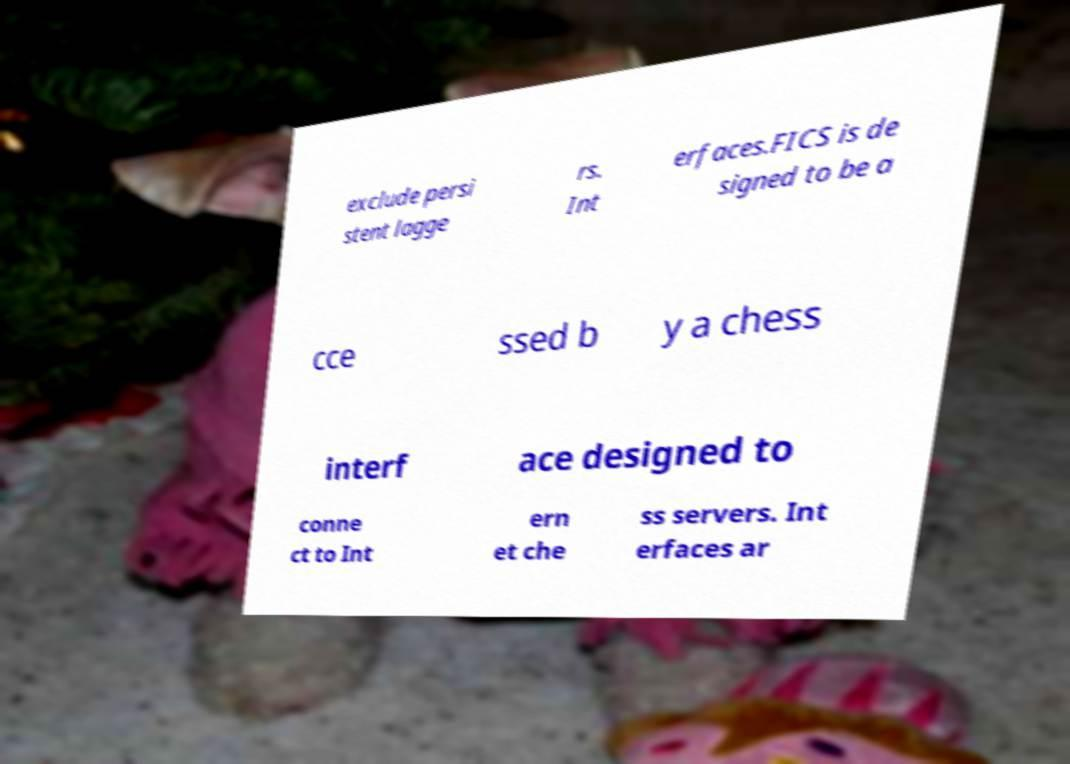Can you accurately transcribe the text from the provided image for me? exclude persi stent lagge rs. Int erfaces.FICS is de signed to be a cce ssed b y a chess interf ace designed to conne ct to Int ern et che ss servers. Int erfaces ar 